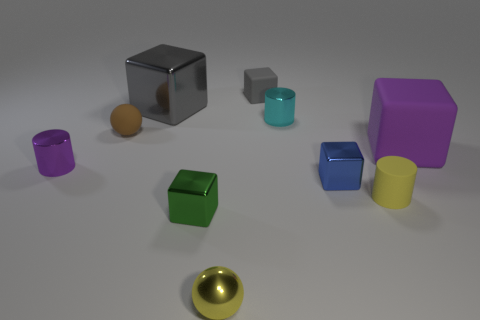Subtract all tiny blue metal cubes. How many cubes are left? 4 Subtract all blue blocks. How many blocks are left? 4 Subtract all cyan blocks. Subtract all cyan balls. How many blocks are left? 5 Subtract all balls. How many objects are left? 8 Add 1 yellow metallic things. How many yellow metallic things are left? 2 Add 7 big brown matte things. How many big brown matte things exist? 7 Subtract 0 blue balls. How many objects are left? 10 Subtract all tiny shiny spheres. Subtract all small purple metal cylinders. How many objects are left? 8 